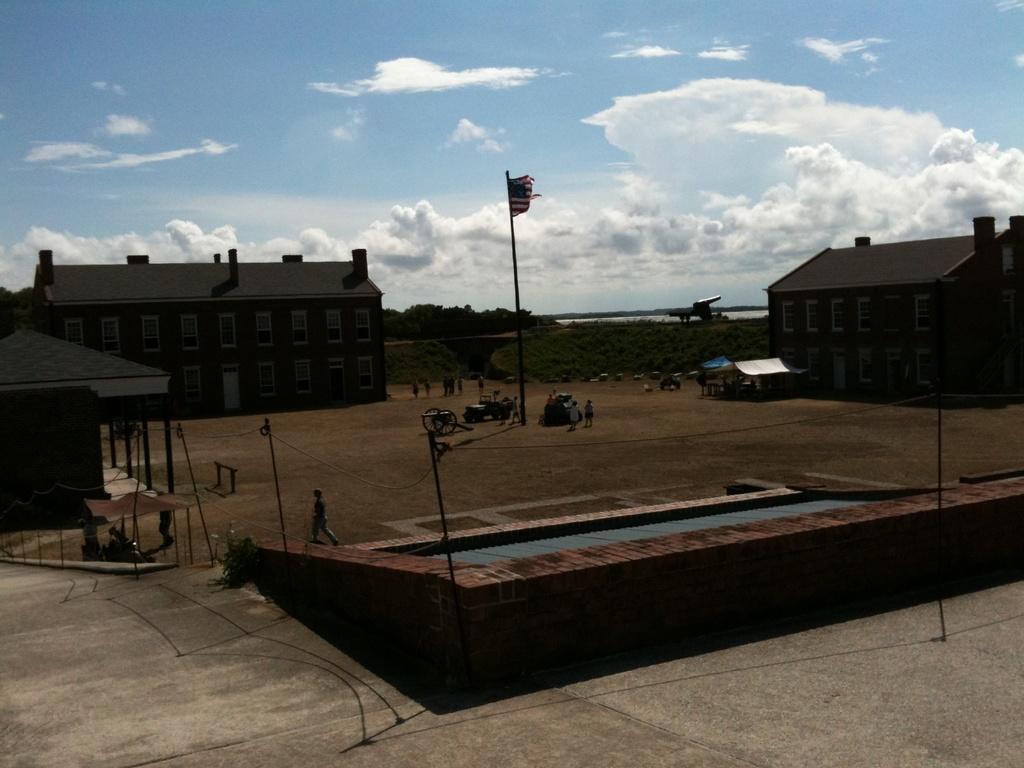How would you summarize this image in a sentence or two? In this image there are poles in the center and there are persons there is a flag. In the background there are buildings, trees, and the sky is cloudy. 